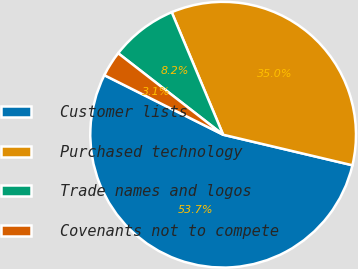<chart> <loc_0><loc_0><loc_500><loc_500><pie_chart><fcel>Customer lists<fcel>Purchased technology<fcel>Trade names and logos<fcel>Covenants not to compete<nl><fcel>53.7%<fcel>35.02%<fcel>8.17%<fcel>3.11%<nl></chart> 